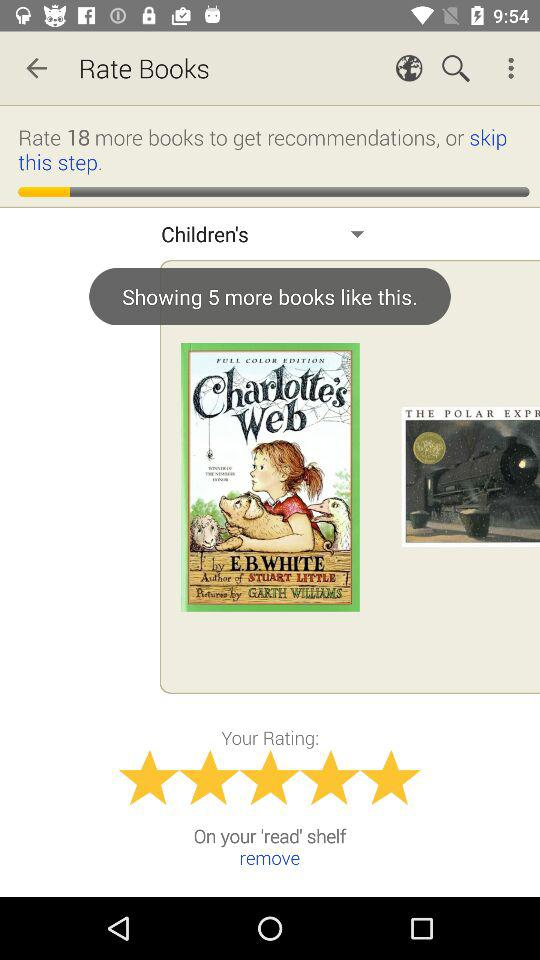How many more books are shown? There are 5 more books shown. 